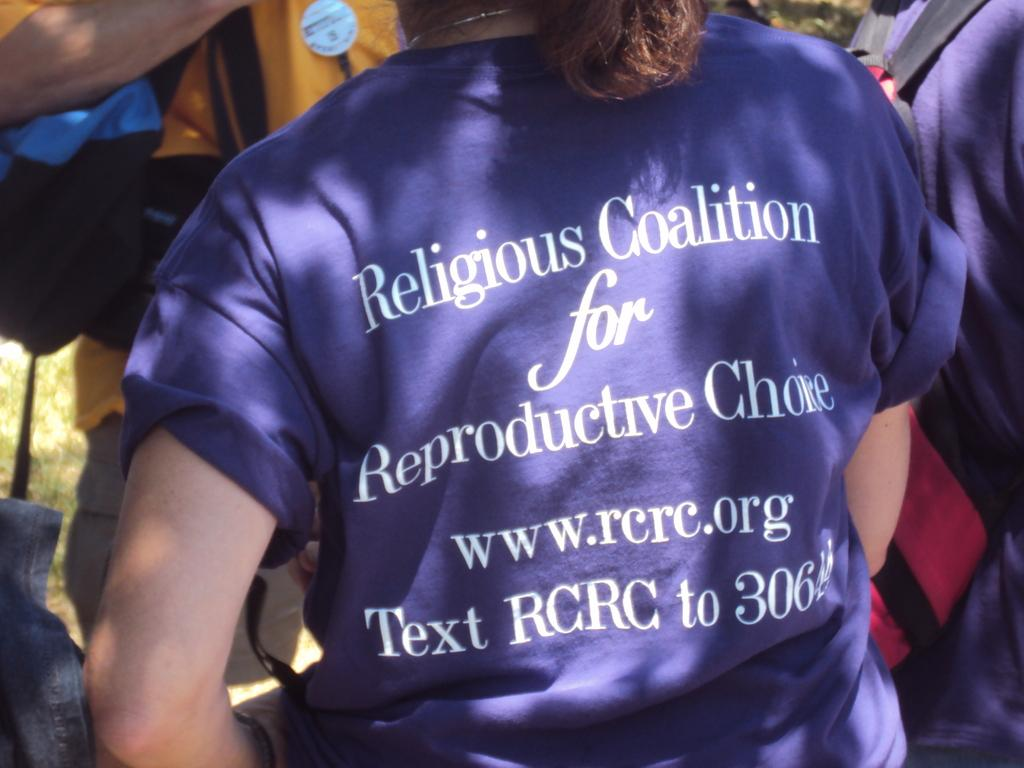<image>
Create a compact narrative representing the image presented. A woman wearing a shirt for the Religious Coalition for Reproductive Choice. 